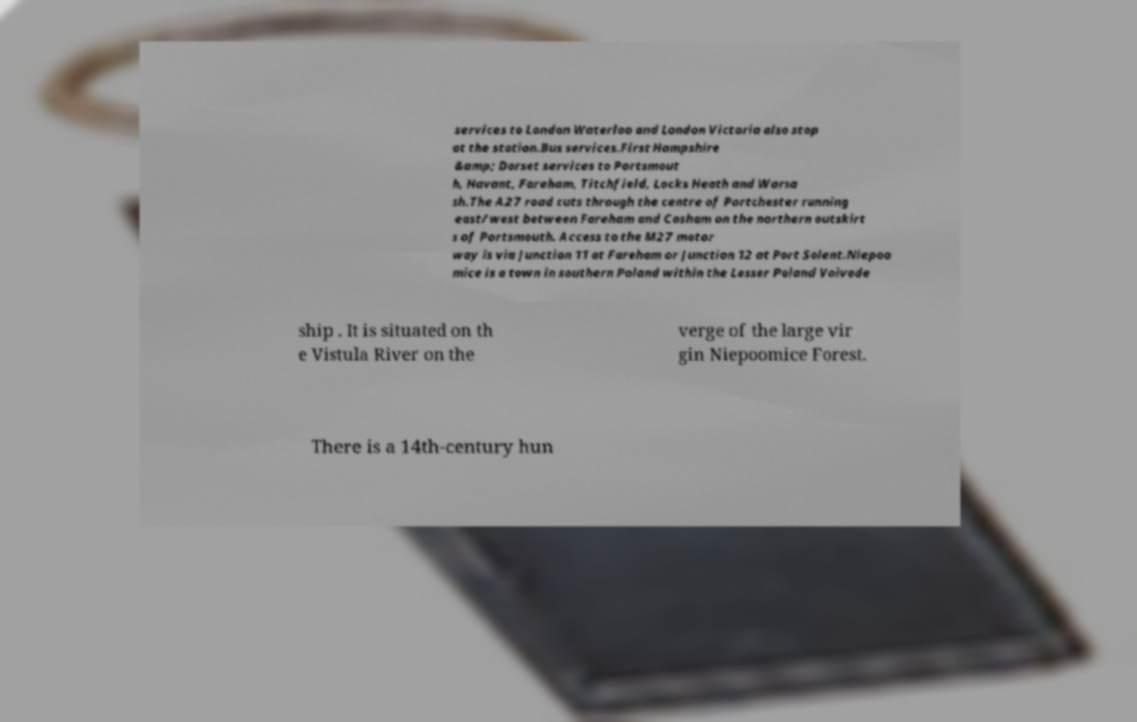Can you read and provide the text displayed in the image?This photo seems to have some interesting text. Can you extract and type it out for me? services to London Waterloo and London Victoria also stop at the station.Bus services.First Hampshire &amp; Dorset services to Portsmout h, Havant, Fareham, Titchfield, Locks Heath and Warsa sh.The A27 road cuts through the centre of Portchester running east/west between Fareham and Cosham on the northern outskirt s of Portsmouth. Access to the M27 motor way is via Junction 11 at Fareham or Junction 12 at Port Solent.Niepoo mice is a town in southern Poland within the Lesser Poland Voivode ship . It is situated on th e Vistula River on the verge of the large vir gin Niepoomice Forest. There is a 14th-century hun 